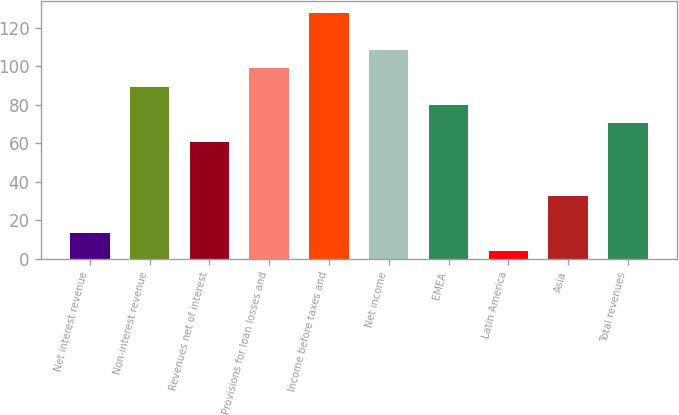<chart> <loc_0><loc_0><loc_500><loc_500><bar_chart><fcel>Net interest revenue<fcel>Non-interest revenue<fcel>Revenues net of interest<fcel>Provisions for loan losses and<fcel>Income before taxes and<fcel>Net income<fcel>EMEA<fcel>Latin America<fcel>Asia<fcel>Total revenues<nl><fcel>13.5<fcel>89.5<fcel>61<fcel>99<fcel>127.5<fcel>108.5<fcel>80<fcel>4<fcel>32.5<fcel>70.5<nl></chart> 